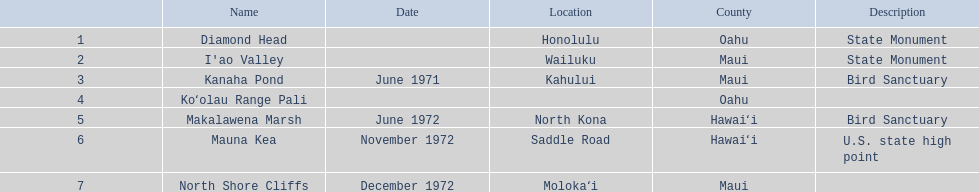What are the titles of all the landmarks? Diamond Head, I'ao Valley, Kanaha Pond, Koʻolau Range Pali, Makalawena Marsh, Mauna Kea, North Shore Cliffs. In which county can each landmark be found? Oahu, Maui, Maui, Oahu, Hawaiʻi, Hawaiʻi, Maui. In addition to mauna kea, which landmark is present in hawai'i county? Makalawena Marsh. 